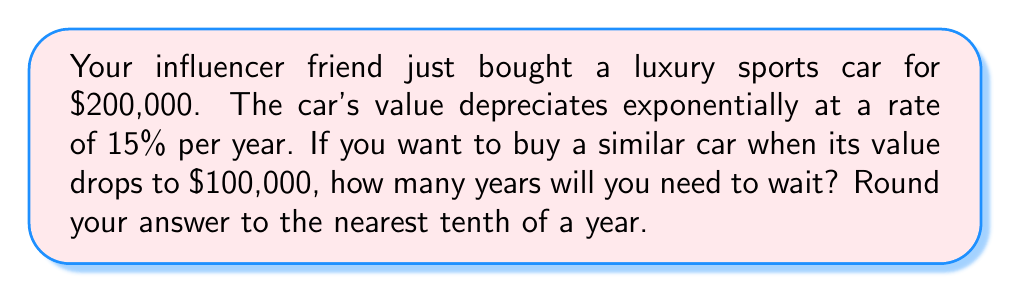Could you help me with this problem? Let's approach this step-by-step:

1) The exponential decay formula for depreciation is:

   $A = P(1-r)^t$

   Where:
   $A$ = Final amount
   $P$ = Initial principal balance
   $r$ = Depreciation rate (as a decimal)
   $t$ = Time in years

2) We know:
   $P = 200,000$
   $r = 0.15$ (15% as a decimal)
   $A = 100,000$ (the value we want it to reach)

3) Let's plug these into our formula:

   $100,000 = 200,000(1-0.15)^t$

4) Simplify:

   $100,000 = 200,000(0.85)^t$

5) Divide both sides by 200,000:

   $0.5 = (0.85)^t$

6) Take the natural log of both sides:

   $\ln(0.5) = \ln((0.85)^t)$

7) Use the logarithm property $\ln(x^n) = n\ln(x)$:

   $\ln(0.5) = t\ln(0.85)$

8) Solve for $t$:

   $t = \frac{\ln(0.5)}{\ln(0.85)}$

9) Use a calculator to compute this:

   $t \approx 4.2659$ years

10) Rounding to the nearest tenth:

    $t \approx 4.3$ years
Answer: You will need to wait approximately 4.3 years for the car's value to depreciate to $100,000. 